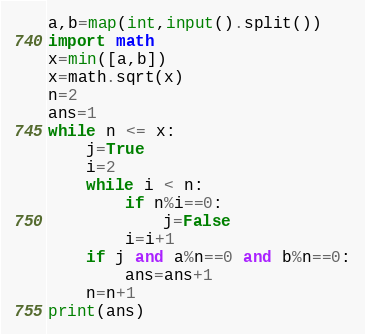<code> <loc_0><loc_0><loc_500><loc_500><_Python_>a,b=map(int,input().split())
import math
x=min([a,b])
x=math.sqrt(x)
n=2
ans=1
while n <= x:
	j=True
	i=2
	while i < n:
		if n%i==0:
			j=False
		i=i+1
	if j and a%n==0 and b%n==0:
		ans=ans+1
	n=n+1        
print(ans)</code> 